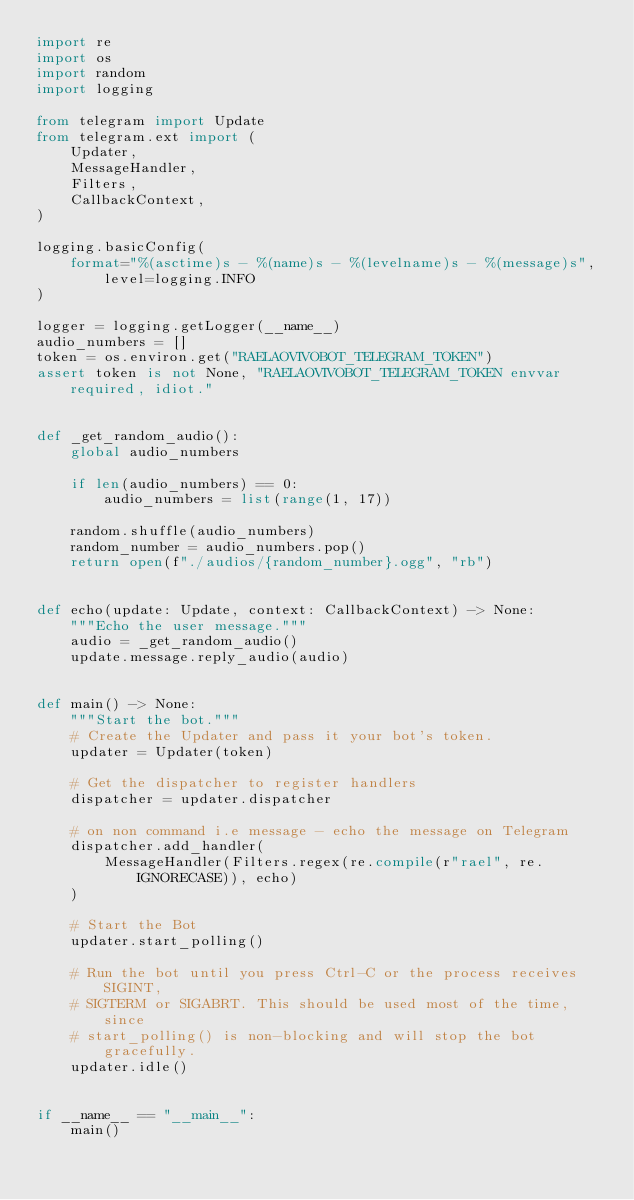Convert code to text. <code><loc_0><loc_0><loc_500><loc_500><_Python_>import re
import os
import random
import logging

from telegram import Update
from telegram.ext import (
    Updater,
    MessageHandler,
    Filters,
    CallbackContext,
)

logging.basicConfig(
    format="%(asctime)s - %(name)s - %(levelname)s - %(message)s", level=logging.INFO
)

logger = logging.getLogger(__name__)
audio_numbers = []
token = os.environ.get("RAELAOVIVOBOT_TELEGRAM_TOKEN")
assert token is not None, "RAELAOVIVOBOT_TELEGRAM_TOKEN envvar required, idiot."


def _get_random_audio():
    global audio_numbers

    if len(audio_numbers) == 0:
        audio_numbers = list(range(1, 17))

    random.shuffle(audio_numbers)
    random_number = audio_numbers.pop()
    return open(f"./audios/{random_number}.ogg", "rb")


def echo(update: Update, context: CallbackContext) -> None:
    """Echo the user message."""
    audio = _get_random_audio()
    update.message.reply_audio(audio)


def main() -> None:
    """Start the bot."""
    # Create the Updater and pass it your bot's token.
    updater = Updater(token)

    # Get the dispatcher to register handlers
    dispatcher = updater.dispatcher

    # on non command i.e message - echo the message on Telegram
    dispatcher.add_handler(
        MessageHandler(Filters.regex(re.compile(r"rael", re.IGNORECASE)), echo)
    )

    # Start the Bot
    updater.start_polling()

    # Run the bot until you press Ctrl-C or the process receives SIGINT,
    # SIGTERM or SIGABRT. This should be used most of the time, since
    # start_polling() is non-blocking and will stop the bot gracefully.
    updater.idle()


if __name__ == "__main__":
    main()
</code> 